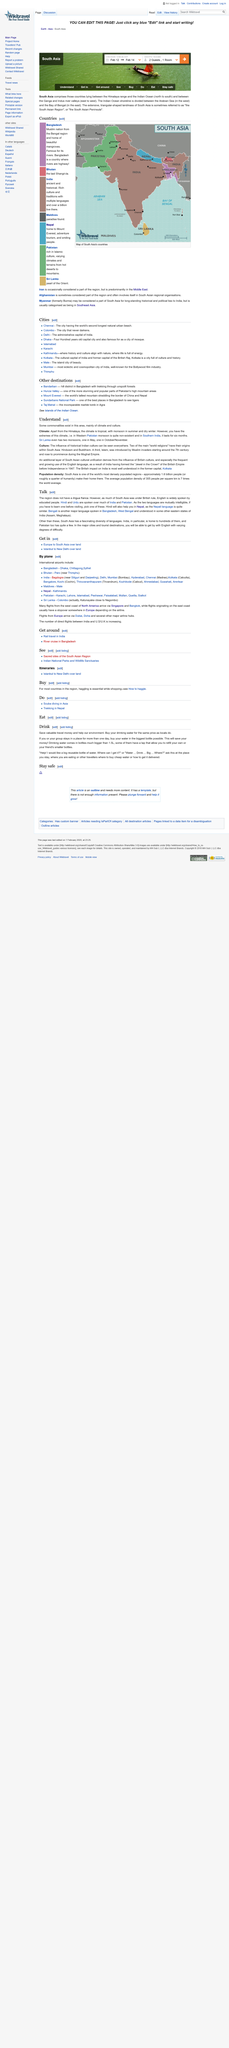Mention a couple of crucial points in this snapshot. It is more cost-effective to buy water in bigger bottles rather than smaller bottles in the long run. The monsoon in Southern India lasts for a period of six months. It is incorrect to conclude that buying water in the smallest possible bottle helps the environment. In fact, it is not helpful at all. Hindi and Urdu, which are spoken over much of India and Pakistan, are the languages that are prevalent in these regions. The existence of commonalities in climate and culture is undeniable in this area. 